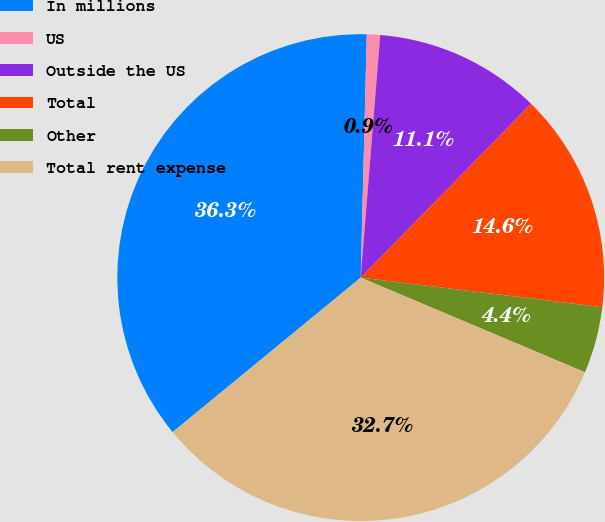Convert chart. <chart><loc_0><loc_0><loc_500><loc_500><pie_chart><fcel>In millions<fcel>US<fcel>Outside the US<fcel>Total<fcel>Other<fcel>Total rent expense<nl><fcel>36.34%<fcel>0.88%<fcel>11.06%<fcel>14.6%<fcel>4.42%<fcel>32.7%<nl></chart> 